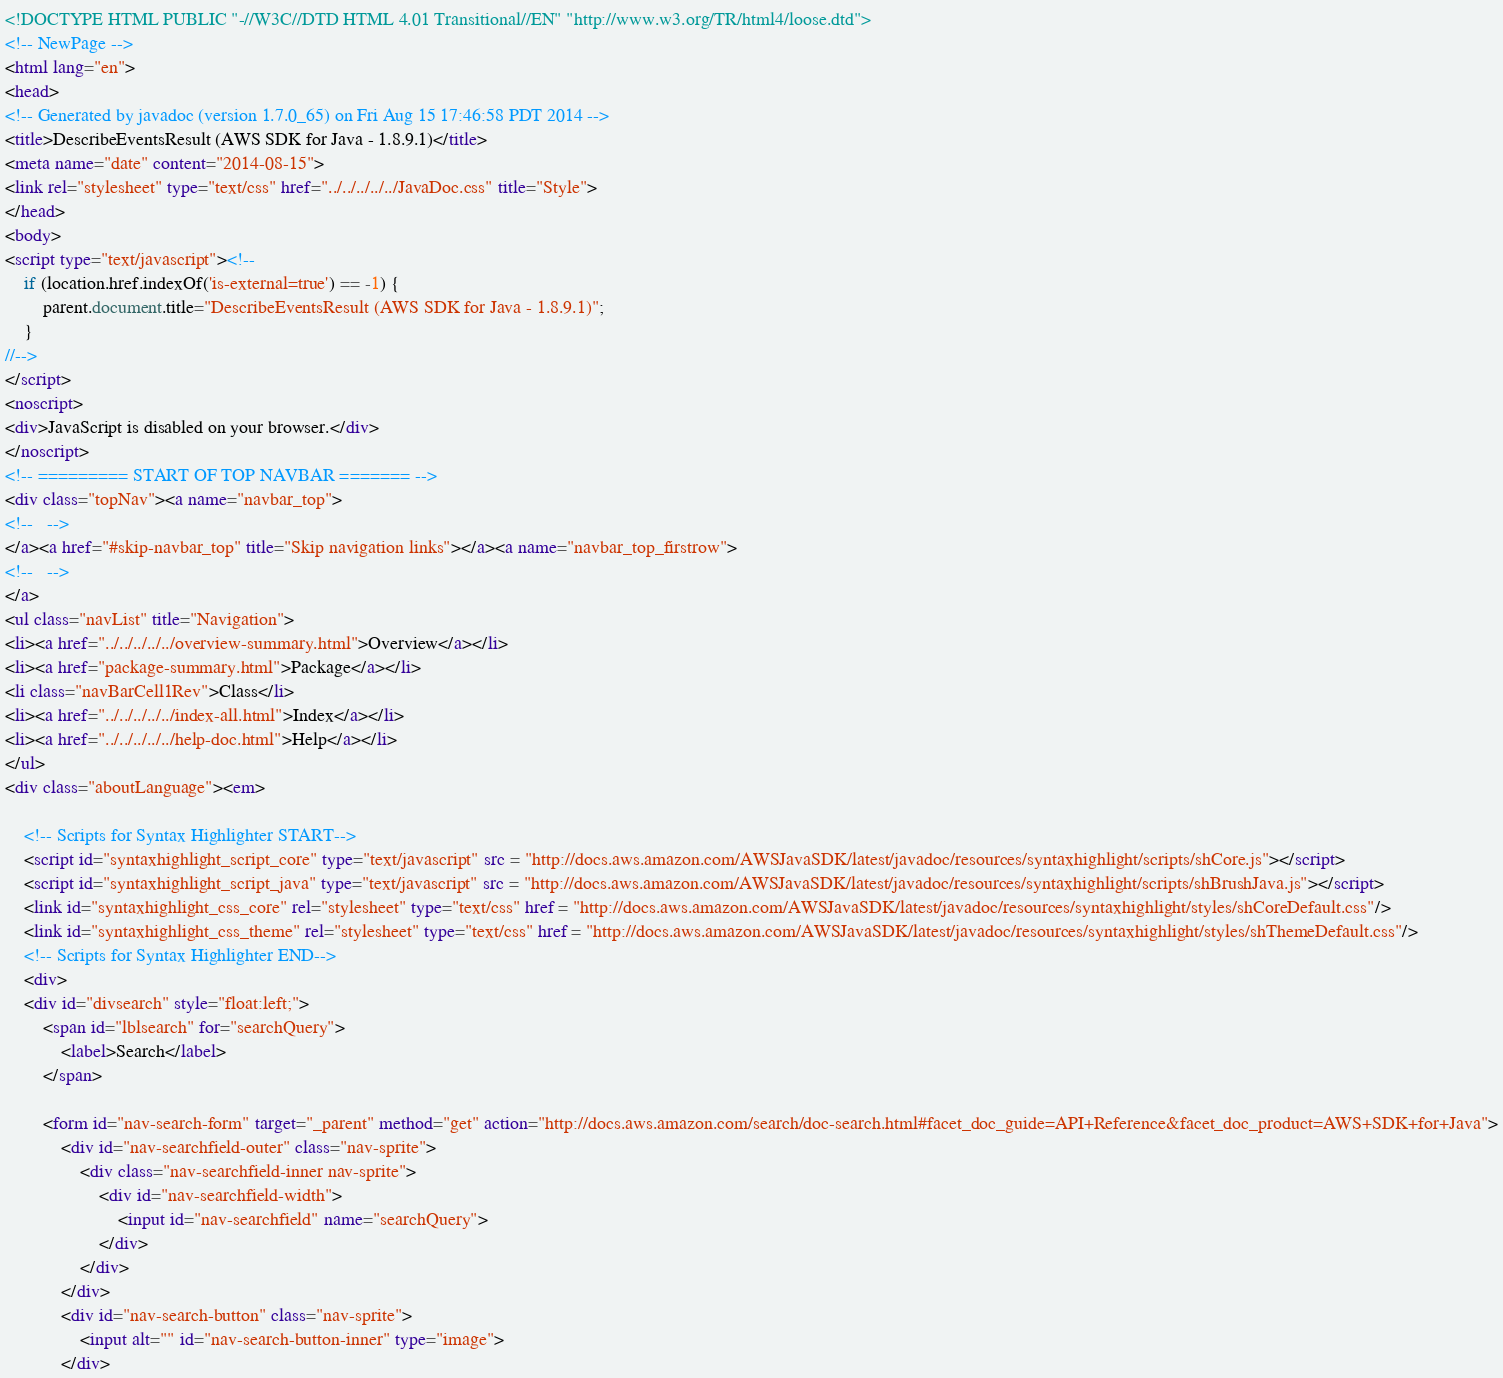<code> <loc_0><loc_0><loc_500><loc_500><_HTML_><!DOCTYPE HTML PUBLIC "-//W3C//DTD HTML 4.01 Transitional//EN" "http://www.w3.org/TR/html4/loose.dtd">
<!-- NewPage -->
<html lang="en">
<head>
<!-- Generated by javadoc (version 1.7.0_65) on Fri Aug 15 17:46:58 PDT 2014 -->
<title>DescribeEventsResult (AWS SDK for Java - 1.8.9.1)</title>
<meta name="date" content="2014-08-15">
<link rel="stylesheet" type="text/css" href="../../../../../JavaDoc.css" title="Style">
</head>
<body>
<script type="text/javascript"><!--
    if (location.href.indexOf('is-external=true') == -1) {
        parent.document.title="DescribeEventsResult (AWS SDK for Java - 1.8.9.1)";
    }
//-->
</script>
<noscript>
<div>JavaScript is disabled on your browser.</div>
</noscript>
<!-- ========= START OF TOP NAVBAR ======= -->
<div class="topNav"><a name="navbar_top">
<!--   -->
</a><a href="#skip-navbar_top" title="Skip navigation links"></a><a name="navbar_top_firstrow">
<!--   -->
</a>
<ul class="navList" title="Navigation">
<li><a href="../../../../../overview-summary.html">Overview</a></li>
<li><a href="package-summary.html">Package</a></li>
<li class="navBarCell1Rev">Class</li>
<li><a href="../../../../../index-all.html">Index</a></li>
<li><a href="../../../../../help-doc.html">Help</a></li>
</ul>
<div class="aboutLanguage"><em>

    <!-- Scripts for Syntax Highlighter START-->
    <script id="syntaxhighlight_script_core" type="text/javascript" src = "http://docs.aws.amazon.com/AWSJavaSDK/latest/javadoc/resources/syntaxhighlight/scripts/shCore.js"></script>
    <script id="syntaxhighlight_script_java" type="text/javascript" src = "http://docs.aws.amazon.com/AWSJavaSDK/latest/javadoc/resources/syntaxhighlight/scripts/shBrushJava.js"></script>
    <link id="syntaxhighlight_css_core" rel="stylesheet" type="text/css" href = "http://docs.aws.amazon.com/AWSJavaSDK/latest/javadoc/resources/syntaxhighlight/styles/shCoreDefault.css"/>
    <link id="syntaxhighlight_css_theme" rel="stylesheet" type="text/css" href = "http://docs.aws.amazon.com/AWSJavaSDK/latest/javadoc/resources/syntaxhighlight/styles/shThemeDefault.css"/>
    <!-- Scripts for Syntax Highlighter END-->
    <div>
    <div id="divsearch" style="float:left;">
        <span id="lblsearch" for="searchQuery">
            <label>Search</label>
        </span>

        <form id="nav-search-form" target="_parent" method="get" action="http://docs.aws.amazon.com/search/doc-search.html#facet_doc_guide=API+Reference&facet_doc_product=AWS+SDK+for+Java">
            <div id="nav-searchfield-outer" class="nav-sprite">
                <div class="nav-searchfield-inner nav-sprite">
                    <div id="nav-searchfield-width">
                        <input id="nav-searchfield" name="searchQuery">
                    </div>
                </div>
            </div>
            <div id="nav-search-button" class="nav-sprite">
                <input alt="" id="nav-search-button-inner" type="image">
            </div></code> 